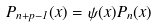<formula> <loc_0><loc_0><loc_500><loc_500>P _ { n + p - 1 } ( x ) = \psi ( x ) P _ { n } ( x )</formula> 